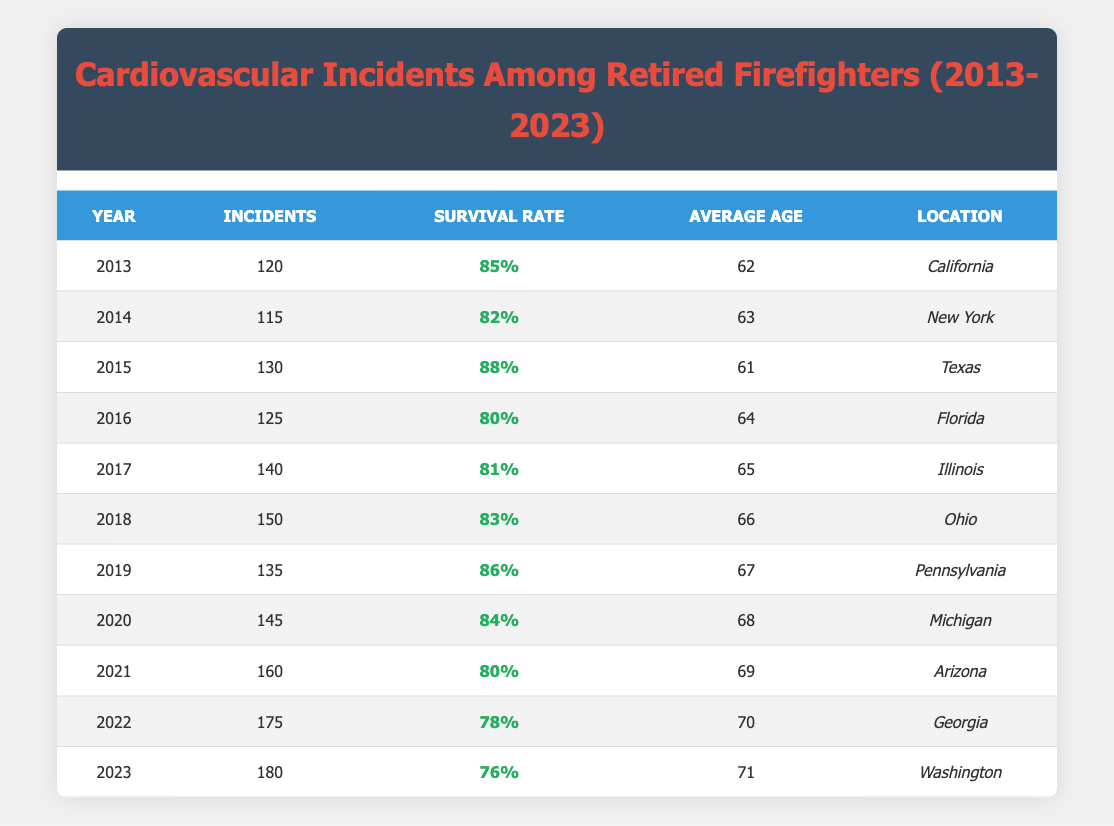What was the survival rate for cardiovascular incidents among retired firefighters in 2015? The table shows that in the year 2015, the survival rate for cardiovascular incidents was listed as 88%.
Answer: 88% In which year did the highest number of cardiovascular incidents occur? Looking at the incidents column, 2023 has the highest number of incidents listed at 180, which is greater than any previous year.
Answer: 2023 What is the average survival rate from 2013 to 2022? To find the average survival rate for these years, we sum the survival rates: (0.85 + 0.82 + 0.88 + 0.80 + 0.81 + 0.83 + 0.86 + 0.84 + 0.80 + 0.78) = 8.47. Then we divide by 10 (the number of years), resulting in an average of 8.47/10 = 0.847 or 84.7%.
Answer: 84.7% Were there more incidents in 2020 than in 2019? By comparing the numbers for these two years, we see that 2020 had 145 incidents while 2019 had 135 incidents, confirming that 2020 had more incidents.
Answer: Yes What trend can be observed in the average age of retired firefighters with cardiovascular incidents over the years? By examining the average age column from 2013 (62 years) to 2023 (71 years), it shows a consistent increase in average age over the decade by 9 years, indicating that the average age is rising.
Answer: Increasing What was the difference in survival rates between the years 2021 and 2019? The survival rate in 2021 is 80% (0.80), while in 2019 it is 86% (0.86). Therefore, the difference in survival rates is 0.86 - 0.80 = 0.06, which is 6%.
Answer: 6% Which state had the highest number of cardiovascular incidents in 2022? According to the table, Georgia had 175 incidents in 2022, which is the highest number listed for that year.
Answer: Georgia Has the survival rate decreased every year from 2020 to 2023? Checking the survival rates: 2020 was 84%, 2021 was 80%, 2022 was 78%, and 2023 was 76%. This indicates that the survival rate dropped each year over this period, confirming the decrease.
Answer: Yes In which year did the average age of retired firefighters reach 70 years? The average age reached 70 years in 2022, as shown in the average age column for that year.
Answer: 2022 